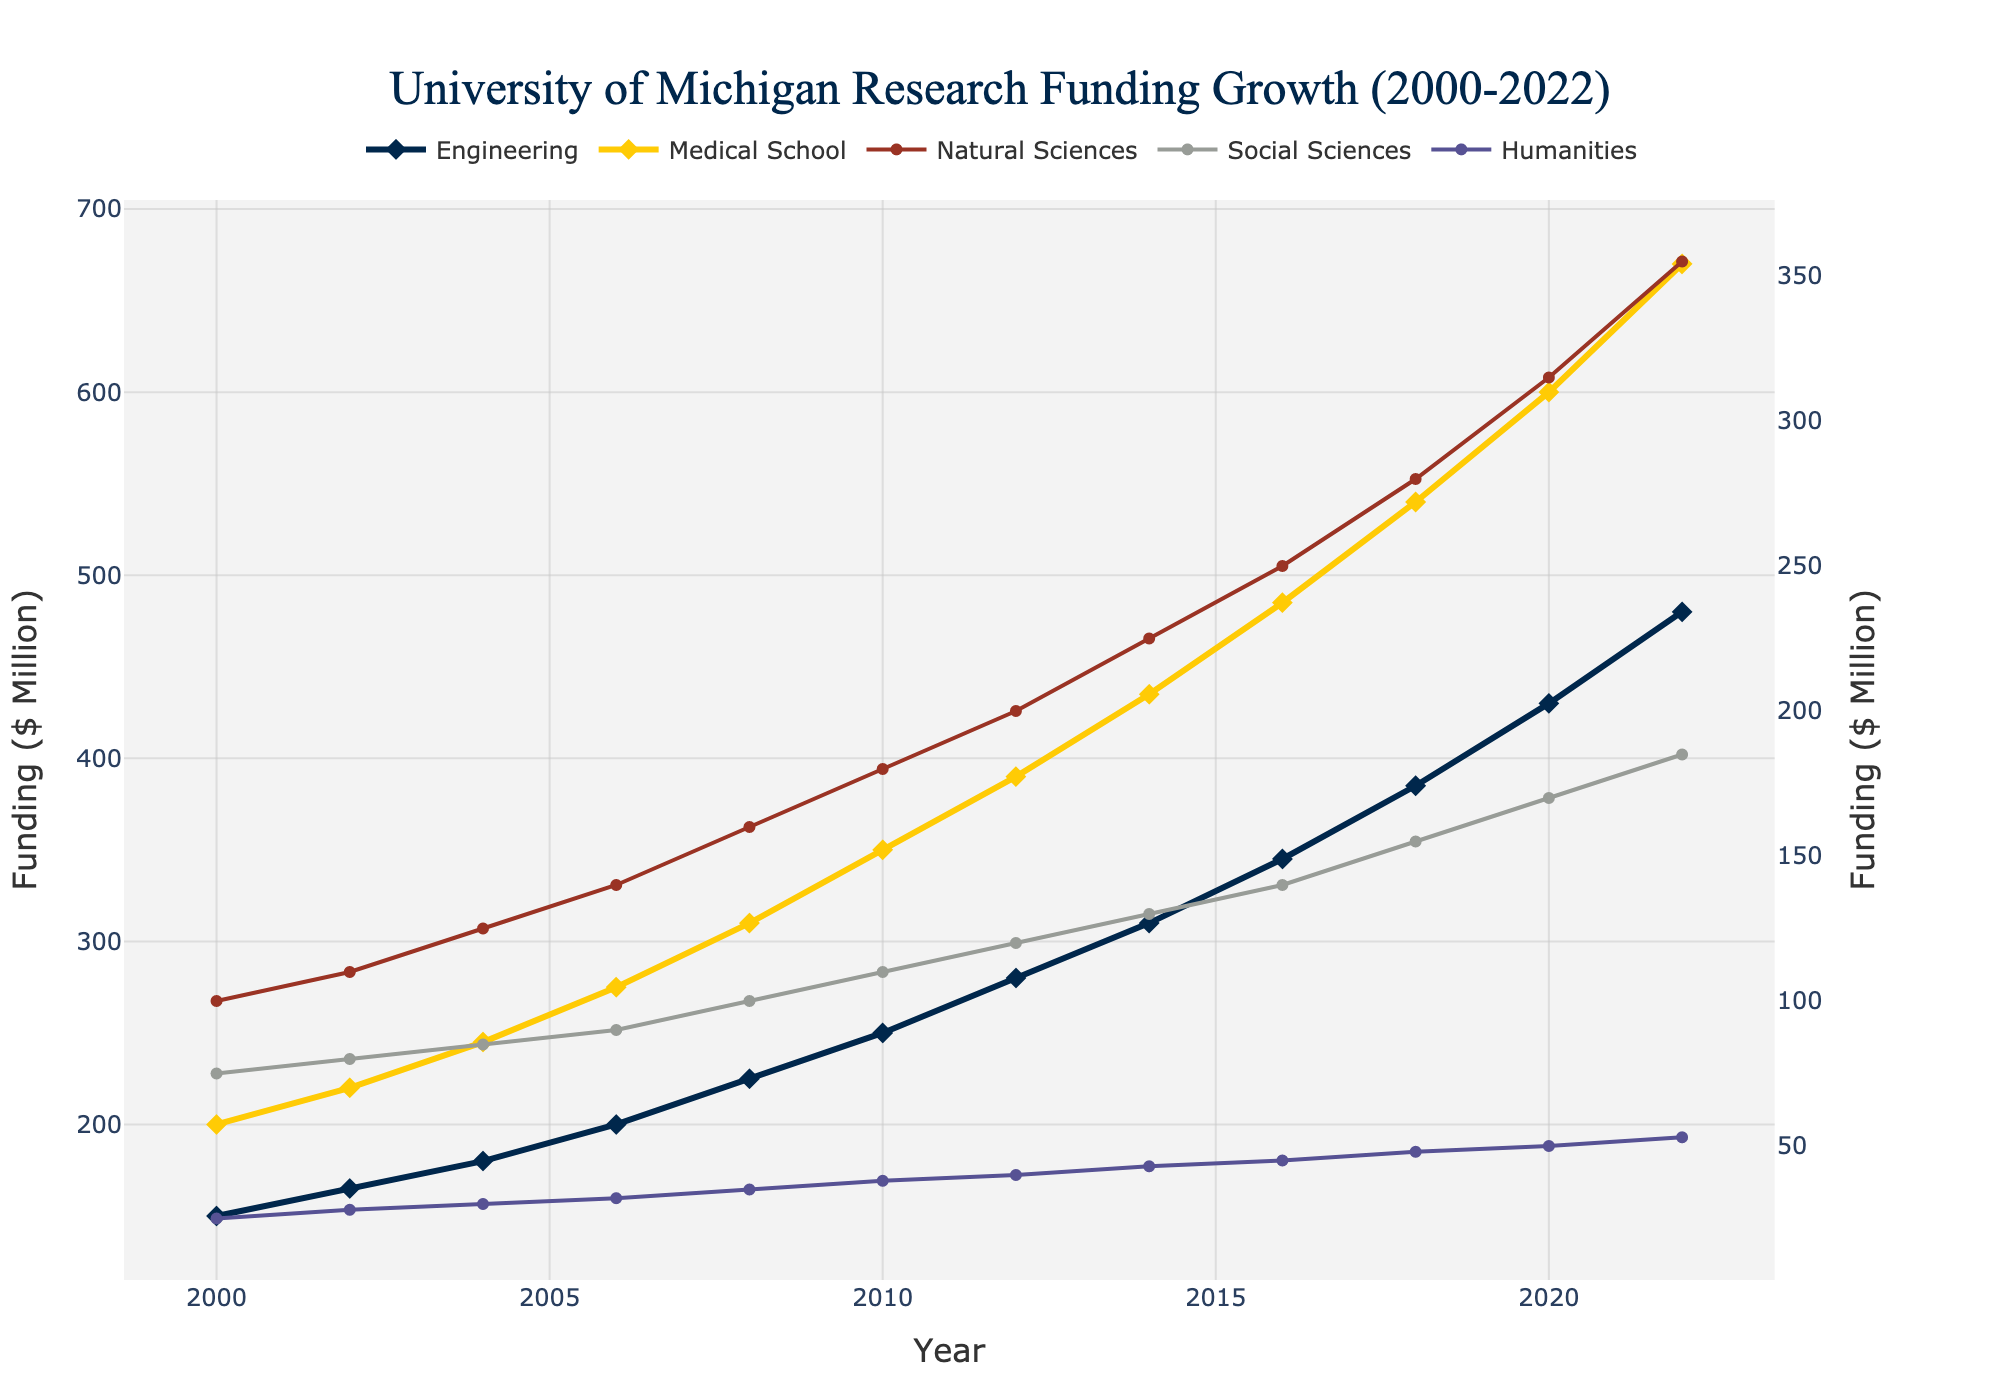What department showed the highest research funding in 2022? By looking at the line chart, the highest point in 2022 is for the Medical School line.
Answer: Medical School How much did research funding for the Natural Sciences department grow between 2008 and 2018? In 2008, funding was $160 million, and by 2018 it was $280 million. The growth is 280 - 160 = 120 million dollars.
Answer: 120 million Which year shows the first instance where research funding for Medical School surpassed 500 million? By observing the chart, the Medical School funding line first crosses the 500-million mark at the year 2018.
Answer: 2018 Compare the research funding growth rate of Engineering from 2000 to 2010 with the Medical School's growth rate in the same period. Which grew faster? Engineering grew from 150 million in 2000 to 250 million in 2010, a 100 million increase. Medical School grew from 200 million in 2000 to 350 million in 2010, a 150 million increase. Thus, the Medical School had faster growth.
Answer: Medical School What was the funding trend for Humanities from 2000 to 2022? The trend line for Humanities shows a steady increase from 25 million in 2000 to 53 million in 2022.
Answer: Steady increase How many years did it take for the Engineering department to increase their research funding from 150 million to 310 million? From the chart, Engineering started with 150 million in 2000 and reached 310 million in 2014. This took 14 years.
Answer: 14 years Is research funding for Social Sciences higher in 2010 or 2018? By comparing the points on the chart, Social Sciences funding in 2010 is 110 million and in 2018 is 155 million. Thus, it was higher in 2018.
Answer: 2018 Calculate the total research funding for the year 2006 for all departments. Summing the values for Engineering (200), Medical School (275), Natural Sciences (140), Social Sciences (90), and Humanities (32) results in 200 + 275 + 140 + 90 + 32 = 737 million.
Answer: 737 million Determine which department had the least research funding in 2004. Observing the chart, the lowest point in 2004 is for the Humanities, at 30 million.
Answer: Humanities 